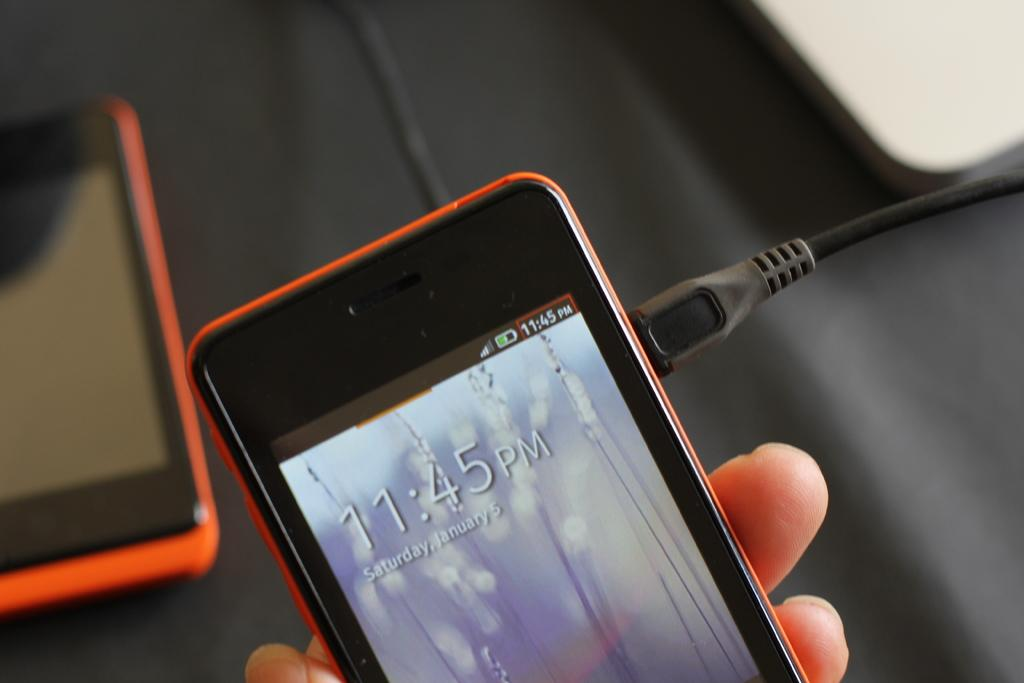Provide a one-sentence caption for the provided image. Fingers holding a cell phone with the display time of 11:45pm and Saturday January 5 under it. 